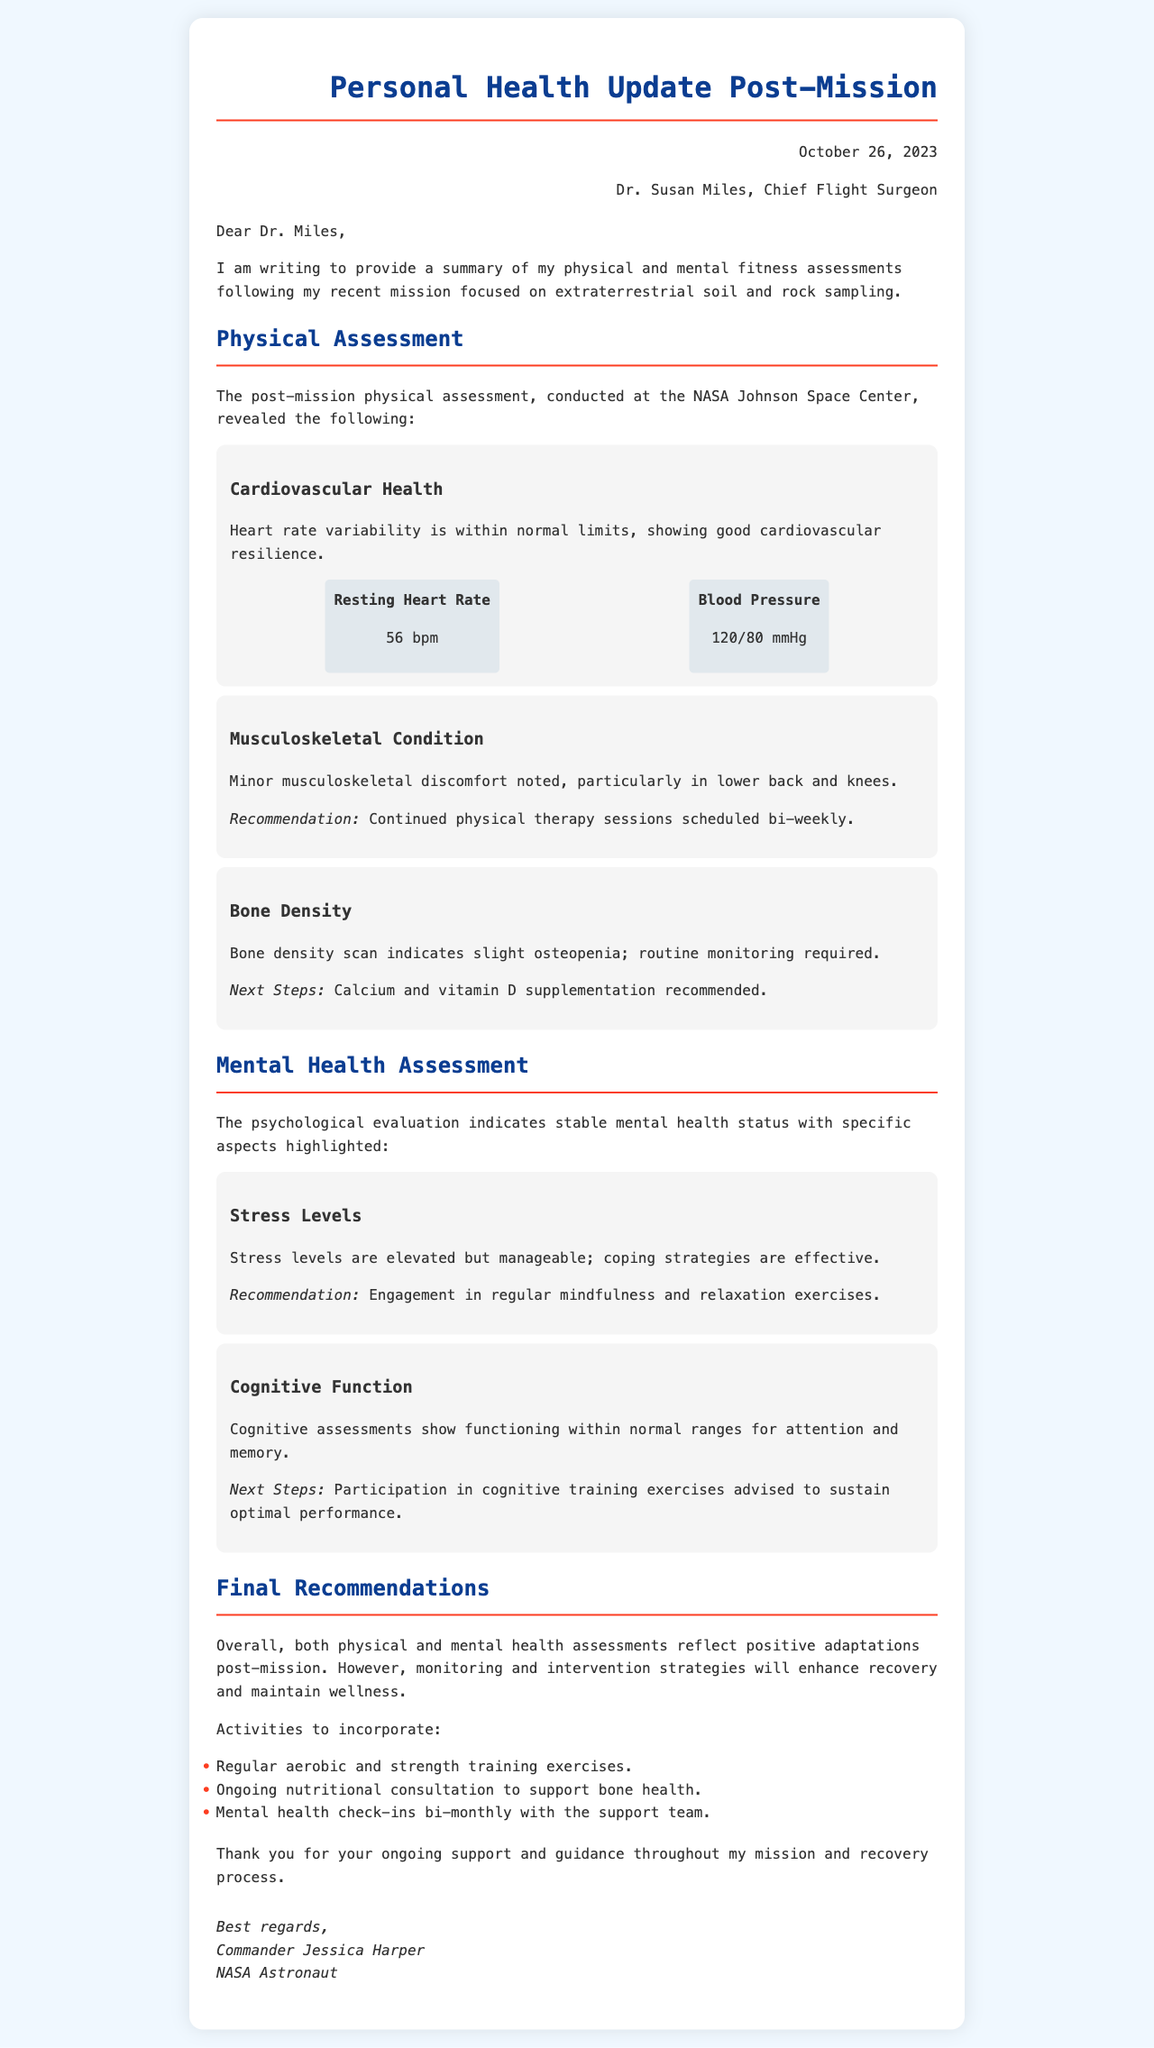What is the date of the personal health update? The date is mentioned prominently at the top of the letter.
Answer: October 26, 2023 Who is the Chief Flight Surgeon? The name of the Chief Flight Surgeon is provided in the header of the document.
Answer: Dr. Susan Miles What was the resting heart rate found in the physical assessment? The document specifically lists the resting heart rate under cardiovascular health metrics.
Answer: 56 bpm What recommendation was made for musculoskeletal discomfort? The document notes recommendations related to musculoskeletal condition, specifically regarding therapy.
Answer: Continued physical therapy sessions scheduled bi-weekly What condition was noted in the bone density scan? The physical assessment discusses findings from the bone density scan, indicating any issues.
Answer: Slight osteopenia What are the stress levels assessed in the mental health evaluation? The mental health section describes the nature of the stress levels found during the evaluations.
Answer: Elevated but manageable What method is suggested for coping with stress? The recommendation for managing stress is mentioned in relation to mental health.
Answer: Engagement in regular mindfulness and relaxation exercises How often should mental health check-ins occur according to the recommendations? The final recommendations section specifies a frequency for mental health check-ins with the support team.
Answer: Bi-monthly 